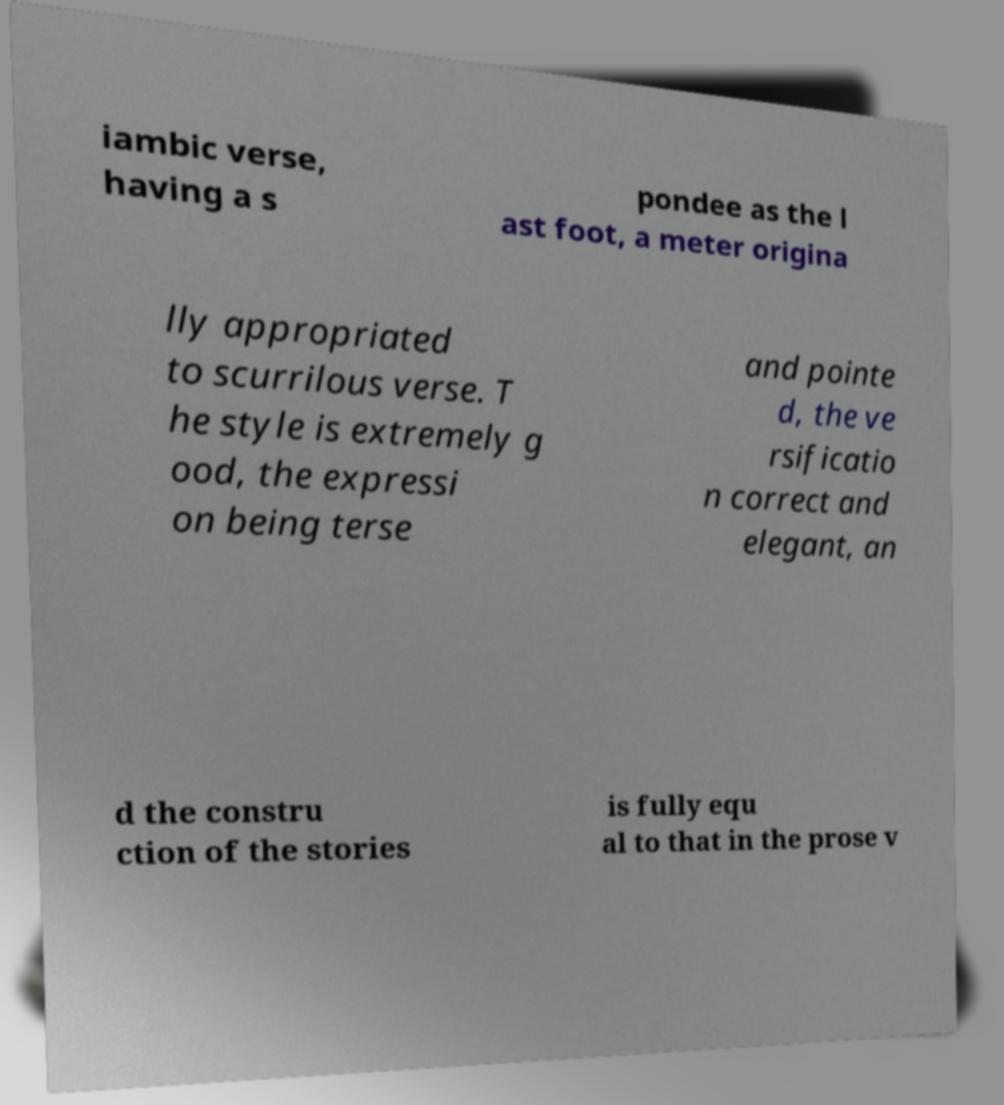I need the written content from this picture converted into text. Can you do that? iambic verse, having a s pondee as the l ast foot, a meter origina lly appropriated to scurrilous verse. T he style is extremely g ood, the expressi on being terse and pointe d, the ve rsificatio n correct and elegant, an d the constru ction of the stories is fully equ al to that in the prose v 